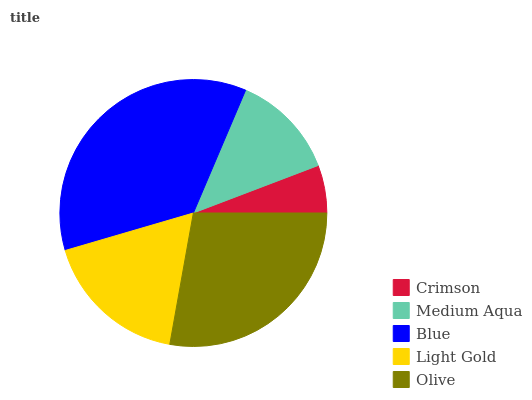Is Crimson the minimum?
Answer yes or no. Yes. Is Blue the maximum?
Answer yes or no. Yes. Is Medium Aqua the minimum?
Answer yes or no. No. Is Medium Aqua the maximum?
Answer yes or no. No. Is Medium Aqua greater than Crimson?
Answer yes or no. Yes. Is Crimson less than Medium Aqua?
Answer yes or no. Yes. Is Crimson greater than Medium Aqua?
Answer yes or no. No. Is Medium Aqua less than Crimson?
Answer yes or no. No. Is Light Gold the high median?
Answer yes or no. Yes. Is Light Gold the low median?
Answer yes or no. Yes. Is Crimson the high median?
Answer yes or no. No. Is Blue the low median?
Answer yes or no. No. 